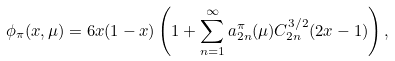<formula> <loc_0><loc_0><loc_500><loc_500>\phi _ { \pi } ( x , \mu ) = 6 x ( 1 - x ) \left ( 1 + \sum _ { n = 1 } ^ { \infty } a _ { 2 n } ^ { \pi } ( \mu ) C ^ { 3 / 2 } _ { 2 n } ( 2 x - 1 ) \right ) ,</formula> 